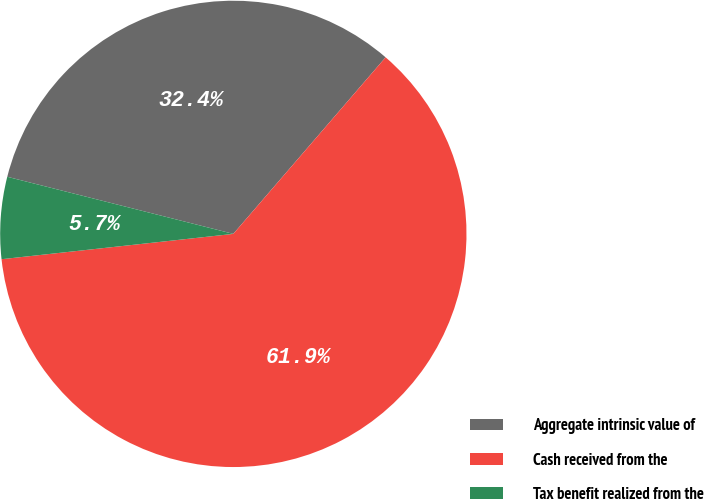<chart> <loc_0><loc_0><loc_500><loc_500><pie_chart><fcel>Aggregate intrinsic value of<fcel>Cash received from the<fcel>Tax benefit realized from the<nl><fcel>32.39%<fcel>61.94%<fcel>5.67%<nl></chart> 